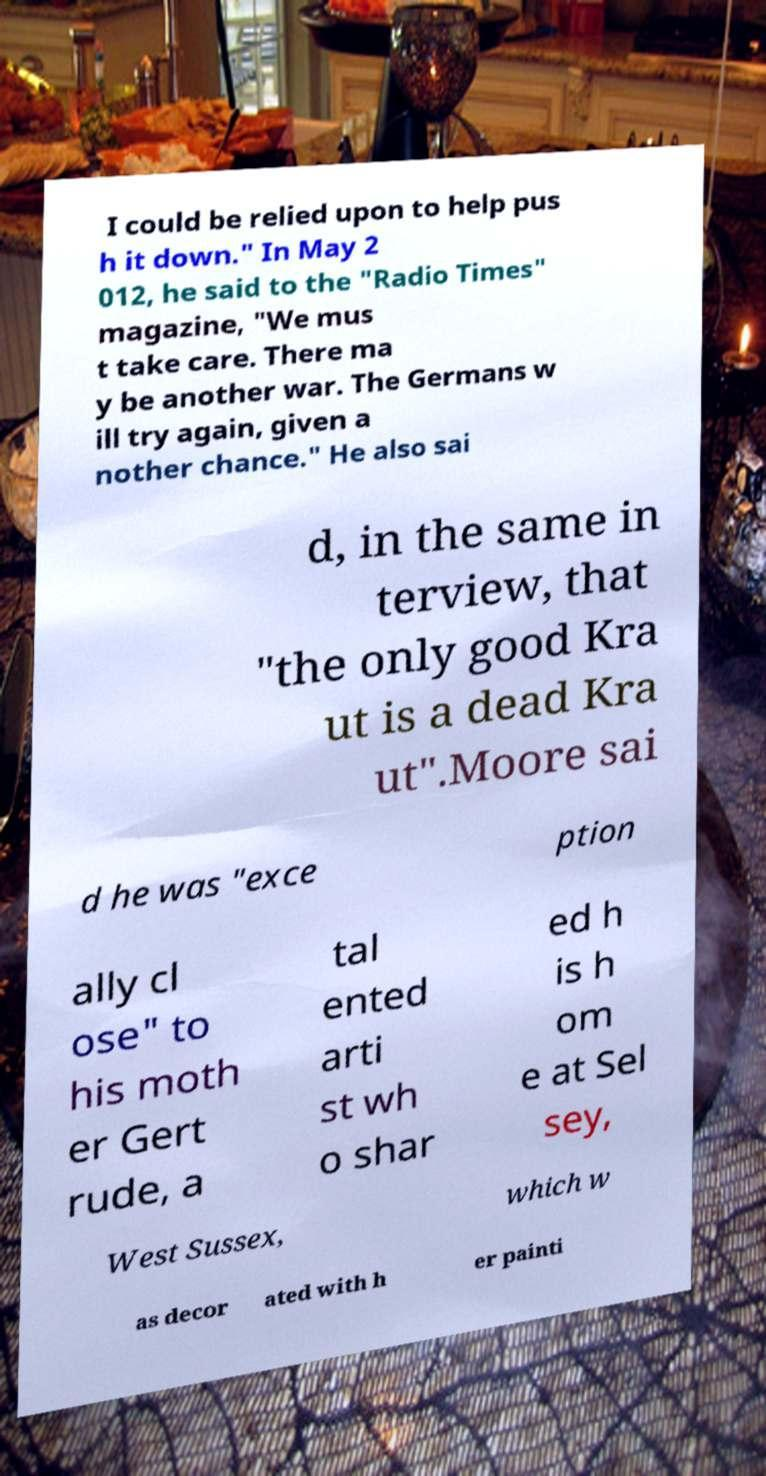Can you accurately transcribe the text from the provided image for me? I could be relied upon to help pus h it down." In May 2 012, he said to the "Radio Times" magazine, "We mus t take care. There ma y be another war. The Germans w ill try again, given a nother chance." He also sai d, in the same in terview, that "the only good Kra ut is a dead Kra ut".Moore sai d he was "exce ption ally cl ose" to his moth er Gert rude, a tal ented arti st wh o shar ed h is h om e at Sel sey, West Sussex, which w as decor ated with h er painti 